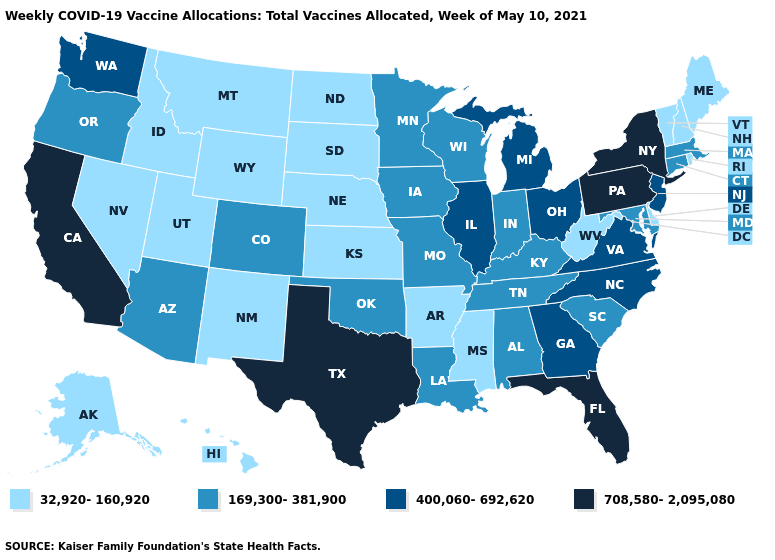Name the states that have a value in the range 169,300-381,900?
Be succinct. Alabama, Arizona, Colorado, Connecticut, Indiana, Iowa, Kentucky, Louisiana, Maryland, Massachusetts, Minnesota, Missouri, Oklahoma, Oregon, South Carolina, Tennessee, Wisconsin. What is the lowest value in states that border New Hampshire?
Write a very short answer. 32,920-160,920. What is the value of Washington?
Answer briefly. 400,060-692,620. Does Alabama have the same value as Louisiana?
Quick response, please. Yes. What is the lowest value in the West?
Keep it brief. 32,920-160,920. Which states have the highest value in the USA?
Write a very short answer. California, Florida, New York, Pennsylvania, Texas. Which states have the highest value in the USA?
Quick response, please. California, Florida, New York, Pennsylvania, Texas. What is the value of Tennessee?
Give a very brief answer. 169,300-381,900. Does Illinois have the same value as New York?
Concise answer only. No. What is the value of Arizona?
Give a very brief answer. 169,300-381,900. What is the lowest value in the Northeast?
Keep it brief. 32,920-160,920. What is the value of Alabama?
Quick response, please. 169,300-381,900. What is the value of Connecticut?
Be succinct. 169,300-381,900. Name the states that have a value in the range 169,300-381,900?
Keep it brief. Alabama, Arizona, Colorado, Connecticut, Indiana, Iowa, Kentucky, Louisiana, Maryland, Massachusetts, Minnesota, Missouri, Oklahoma, Oregon, South Carolina, Tennessee, Wisconsin. 